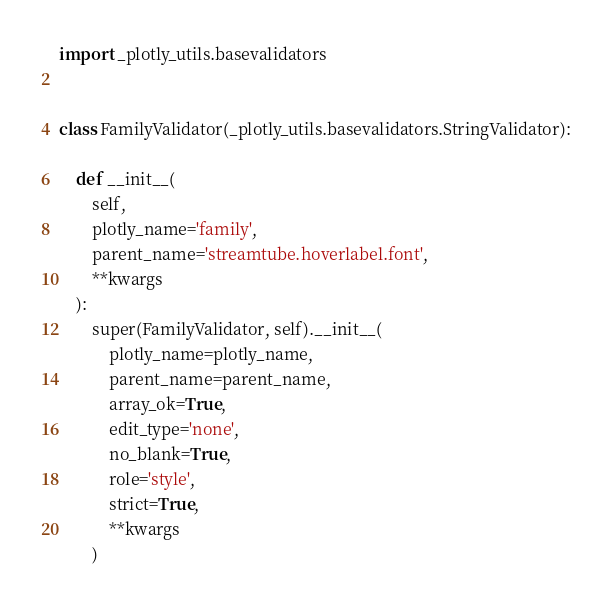Convert code to text. <code><loc_0><loc_0><loc_500><loc_500><_Python_>import _plotly_utils.basevalidators


class FamilyValidator(_plotly_utils.basevalidators.StringValidator):

    def __init__(
        self,
        plotly_name='family',
        parent_name='streamtube.hoverlabel.font',
        **kwargs
    ):
        super(FamilyValidator, self).__init__(
            plotly_name=plotly_name,
            parent_name=parent_name,
            array_ok=True,
            edit_type='none',
            no_blank=True,
            role='style',
            strict=True,
            **kwargs
        )
</code> 